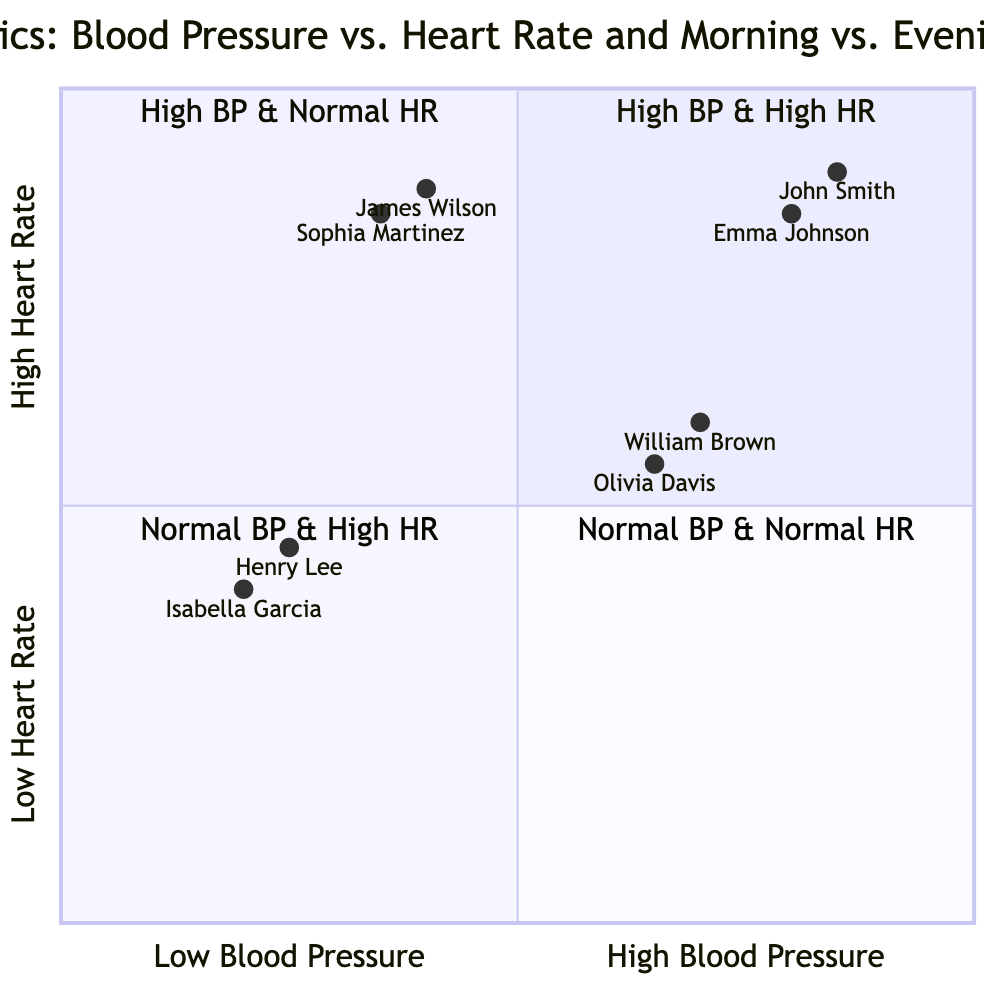What entities are in Quadrant 1? Quadrant 1 contains examples of both high blood pressure and high heart rate. The entities listed are John Smith in the morning and Emma Johnson in the evening.
Answer: John Smith, Emma Johnson How many entities are in Quadrant 3? Quadrant 3 features two entities, James Wilson in the morning and Sophia Martinez in the evening, both showing normal blood pressure but high heart rate.
Answer: 2 What is the blood pressure reading for Olivia Davis? Olivia Davis is located in Quadrant 2, which is marked by high blood pressure and normal heart rate. Her blood pressure reading is 135/88.
Answer: 135/88 Which quadrant has the lowest average heart rate? Quadrant 4, which includes Henry Lee and Isabella Garcia, has the lowest heart rates of 68 and 65 respectively, averaging to a lower value compared to others.
Answer: Quadrant 4 What is the heart rate of John Smith? John Smith, featured in Quadrant 1, has a heart rate of 90. This is part of his overall profile of high blood pressure and high heart rate.
Answer: 90 Who has high blood pressure with a normal heart rate in the morning? The individual with high blood pressure and a normal heart rate in the morning is William Brown, who has a blood pressure reading of 140/92 and a heart rate of 72.
Answer: William Brown Which entity has the highest blood pressure reading? Among the listed entities, John Smith has the highest blood pressure reading at 150/95, which places him in Quadrant 1.
Answer: John Smith What is the average blood pressure in Quadrant 4? Quadrant 4 consists of Henry Lee and Isabella Garcia, with blood pressure readings of 115/75 and 110/72 respectively. The average systolic and diastolic can be calculated from these values.
Answer: (112.5/73.5) 